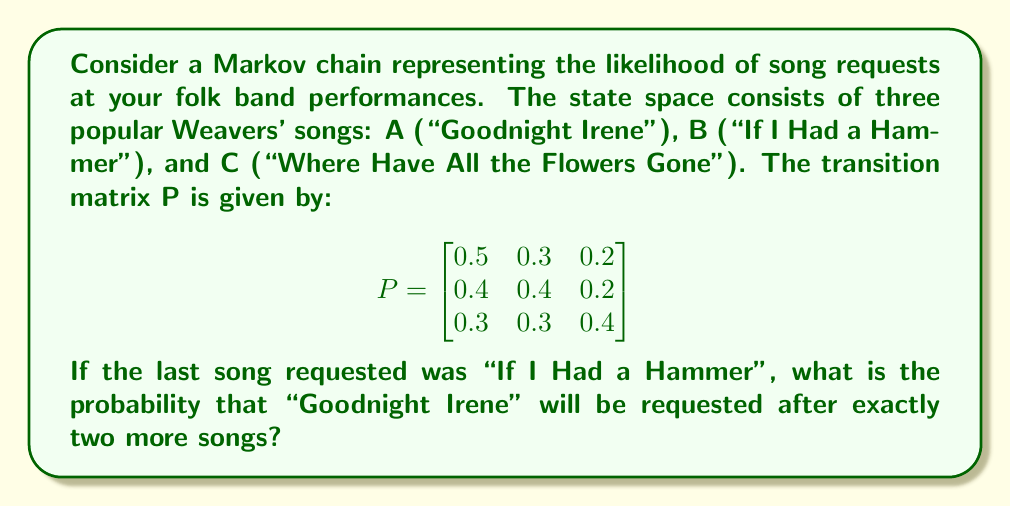Give your solution to this math problem. To solve this problem, we need to use the Chapman-Kolmogorov equations and calculate the two-step transition probability.

Step 1: Identify the initial state and target state.
- Initial state: B ("If I Had a Hammer")
- Target state: A ("Goodnight Irene")

Step 2: Calculate the two-step transition probability matrix by squaring the given transition matrix P.

$$P^2 = P \times P = \begin{bmatrix}
0.5 & 0.3 & 0.2 \\
0.4 & 0.4 & 0.2 \\
0.3 & 0.3 & 0.4
\end{bmatrix} \times \begin{bmatrix}
0.5 & 0.3 & 0.2 \\
0.4 & 0.4 & 0.2 \\
0.3 & 0.3 & 0.4
\end{bmatrix}$$

Step 3: Perform the matrix multiplication.

$$P^2 = \begin{bmatrix}
(0.5)(0.5) + (0.3)(0.4) + (0.2)(0.3) & (0.5)(0.3) + (0.3)(0.4) + (0.2)(0.3) & (0.5)(0.2) + (0.3)(0.2) + (0.2)(0.4) \\
(0.4)(0.5) + (0.4)(0.4) + (0.2)(0.3) & (0.4)(0.3) + (0.4)(0.4) + (0.2)(0.3) & (0.4)(0.2) + (0.4)(0.2) + (0.2)(0.4) \\
(0.3)(0.5) + (0.3)(0.4) + (0.4)(0.3) & (0.3)(0.3) + (0.3)(0.4) + (0.4)(0.3) & (0.3)(0.2) + (0.3)(0.2) + (0.4)(0.4)
\end{bmatrix}$$

$$P^2 = \begin{bmatrix}
0.43 & 0.33 & 0.24 \\
0.41 & 0.37 & 0.22 \\
0.39 & 0.33 & 0.28
\end{bmatrix}$$

Step 4: The probability of transitioning from state B to state A in exactly two steps is given by the element in the second row, first column of $P^2$.

Therefore, the probability of "Goodnight Irene" being requested after exactly two more songs, given that "If I Had a Hammer" was the last requested song, is 0.41 or 41%.
Answer: 0.41 